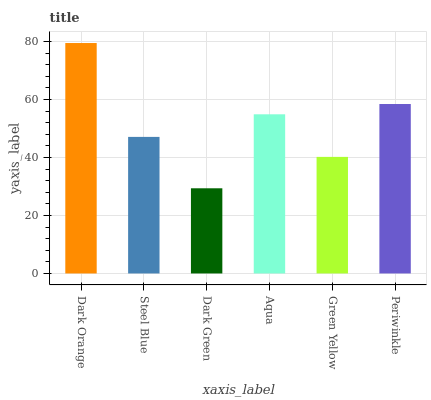Is Dark Green the minimum?
Answer yes or no. Yes. Is Dark Orange the maximum?
Answer yes or no. Yes. Is Steel Blue the minimum?
Answer yes or no. No. Is Steel Blue the maximum?
Answer yes or no. No. Is Dark Orange greater than Steel Blue?
Answer yes or no. Yes. Is Steel Blue less than Dark Orange?
Answer yes or no. Yes. Is Steel Blue greater than Dark Orange?
Answer yes or no. No. Is Dark Orange less than Steel Blue?
Answer yes or no. No. Is Aqua the high median?
Answer yes or no. Yes. Is Steel Blue the low median?
Answer yes or no. Yes. Is Green Yellow the high median?
Answer yes or no. No. Is Dark Green the low median?
Answer yes or no. No. 